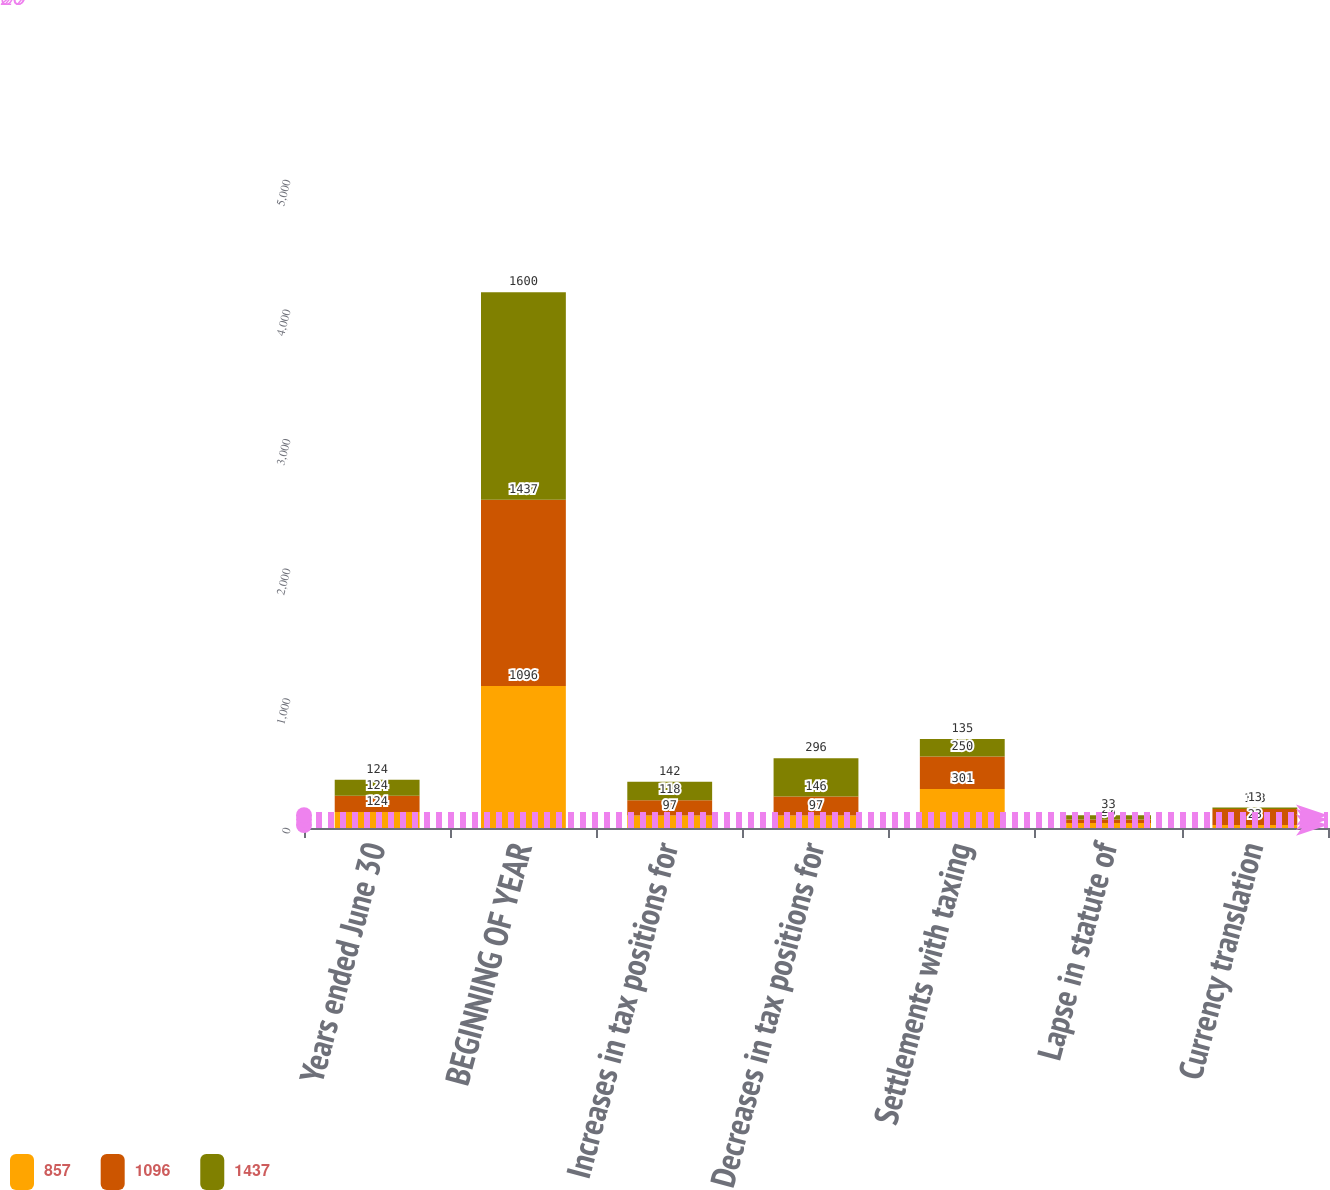Convert chart to OTSL. <chart><loc_0><loc_0><loc_500><loc_500><stacked_bar_chart><ecel><fcel>Years ended June 30<fcel>BEGINNING OF YEAR<fcel>Increases in tax positions for<fcel>Decreases in tax positions for<fcel>Settlements with taxing<fcel>Lapse in statute of<fcel>Currency translation<nl><fcel>857<fcel>124<fcel>1096<fcel>97<fcel>97<fcel>301<fcel>39<fcel>23<nl><fcel>1096<fcel>124<fcel>1437<fcel>118<fcel>146<fcel>250<fcel>27<fcel>123<nl><fcel>1437<fcel>124<fcel>1600<fcel>142<fcel>296<fcel>135<fcel>33<fcel>13<nl></chart> 